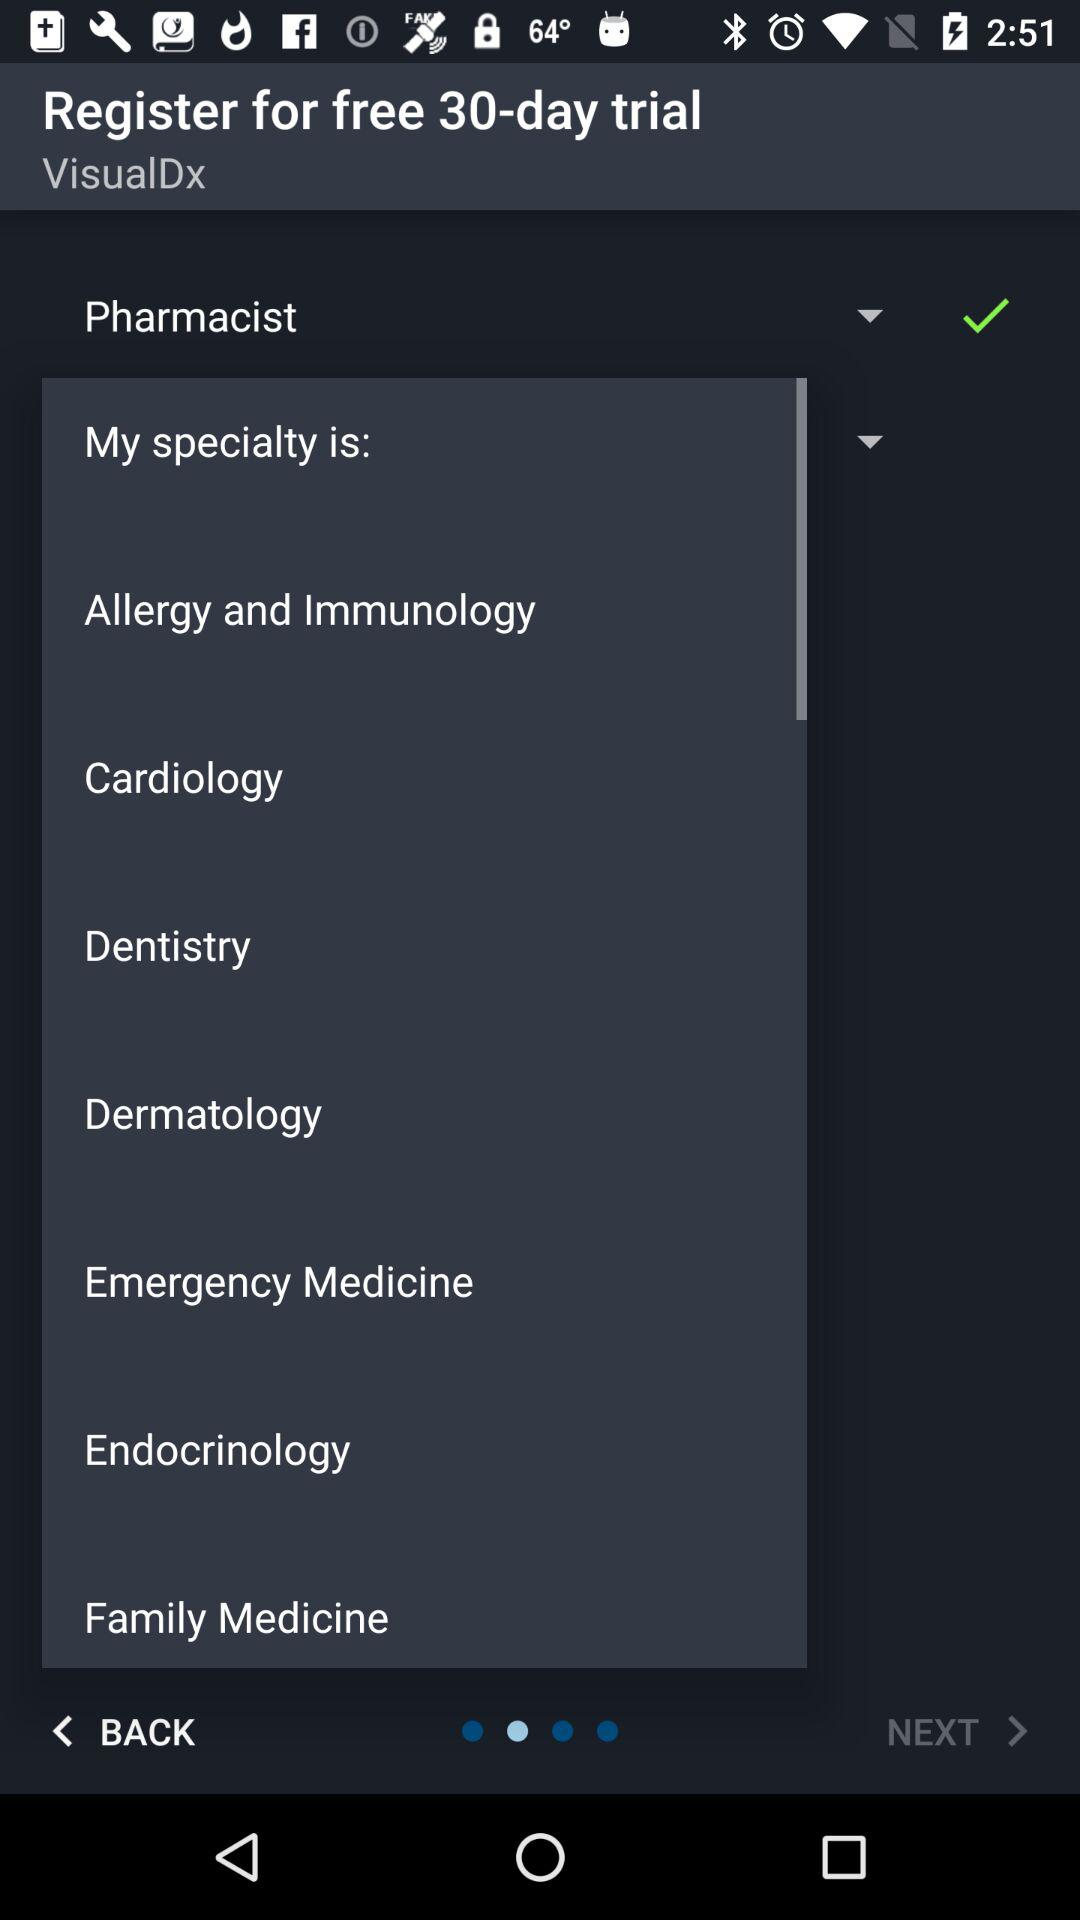How many days does the available free trial last? The available free trial lasts for 30 days. 